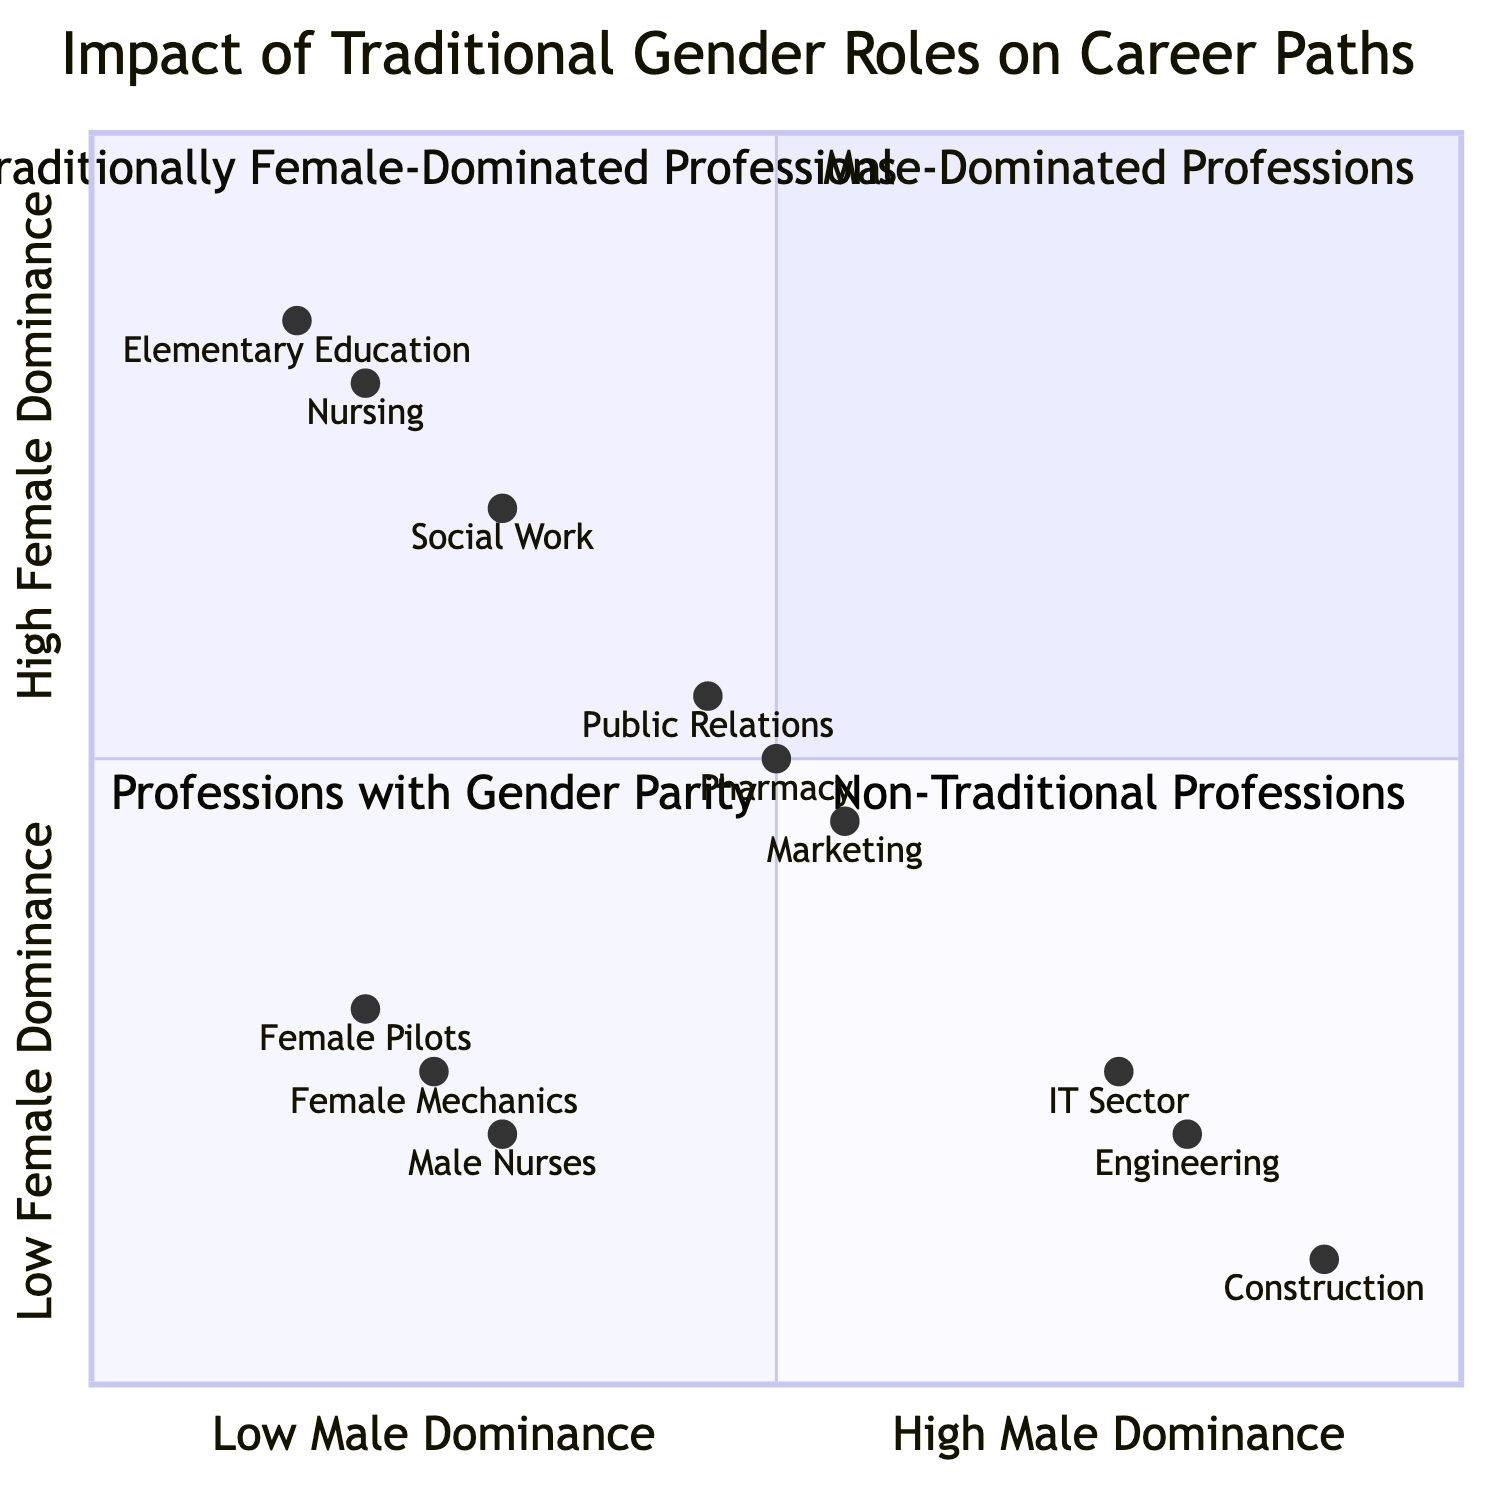What professions are found in the Male-Dominated Professions quadrant? The Male-Dominated Professions quadrant includes Engineering, Construction, and IT Sector as examples.
Answer: Engineering, Construction, IT Sector Which profession has the highest female dominance? The profession with the highest female dominance is Nursing, as it is located at the highest point on the Y-axis in the Traditionally Female-Dominated Professions quadrant.
Answer: Nursing What is the impact of the professions in the Non-Traditional Professions quadrant? The impact of the Non-Traditional Professions quadrant is described as breaking stereotypes and facing societal challenges, indicating a nuanced effect of traditional gender roles.
Answer: Breaking stereotypes, facing societal challenges Which quadrant contains Pharmacy? Pharmacy is located in the Professions with Gender Parity quadrant, which is positioned in the center of the chart.
Answer: Professions with Gender Parity How many examples are there in the Traditionally Female-Dominated Professions quadrant? There are three examples listed in the Traditionally Female-Dominated Professions quadrant: Nursing, Elementary Education, and Social Work.
Answer: Three Which profession has the lowest representation of females? The profession with the lowest representation of females is Engineering, as it has the highest male dominance values.
Answer: Engineering What is the earning potential associated with Male-Dominated Professions? The earning potential associated with Male-Dominated Professions is characterized as high for males, representing a significant implication of traditional gender roles.
Answer: High earning potential for males What is the significance of the Professions with Gender Parity quadrant? The significance of the Professions with Gender Parity quadrant is the balanced representation and equitable opportunities for both genders, indicating a positive effect of gender norms.
Answer: Balanced representation, equitable opportunities 